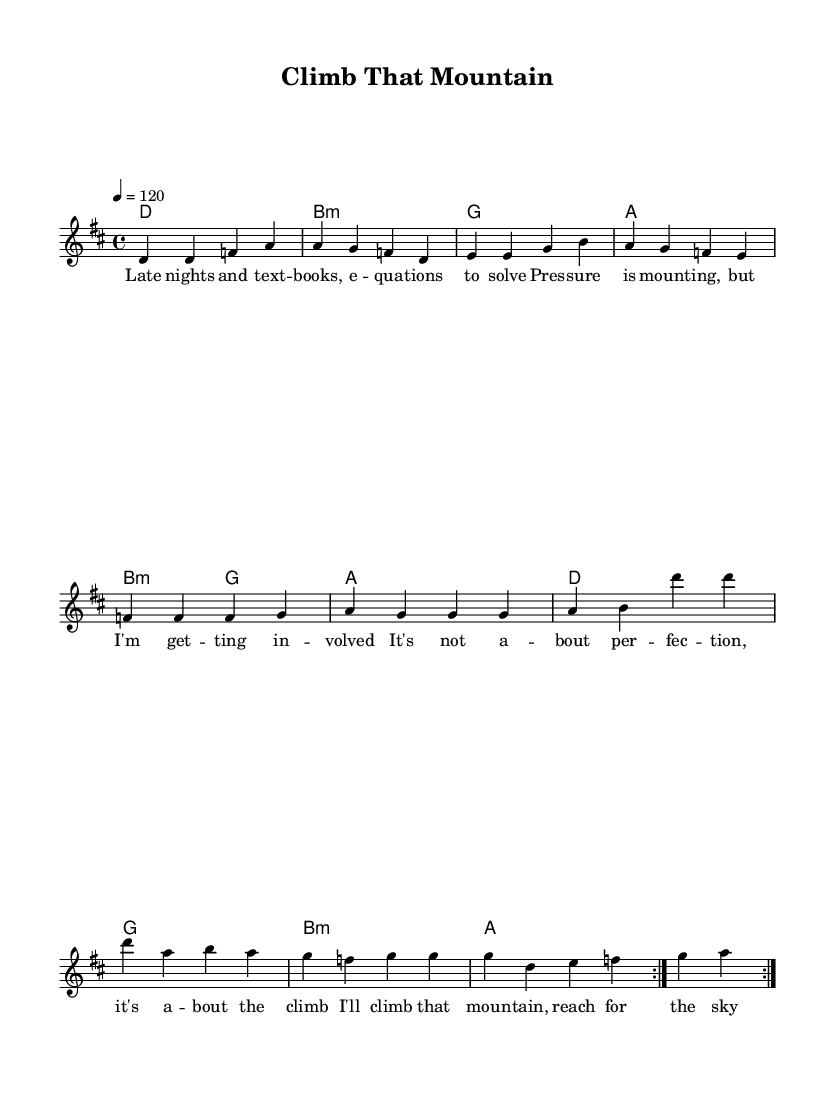What is the key signature of this music? The key signature is indicated at the beginning of the sheet music, showing two sharps, which corresponds to D major.
Answer: D major What is the time signature? The time signature is noted right after the key signature, represented by "4/4," which means there are four beats in each measure.
Answer: 4/4 What is the tempo marking for this piece? The tempo marking is given as "4 = 120," indicating that the quarter note is to be played at a speed of 120 beats per minute.
Answer: 120 How many repetitions are indicated in the melody section? The music notation includes a "repeat volta 2" directive, indicating that the melody should be played twice.
Answer: 2 What type of song is "Climb That Mountain"? The lyrics suggest a theme of perseverance and motivation, categorizing it as a motivational rock anthem.
Answer: Motivational rock anthem How many chords are used in the harmony section? The harmony section lists specific chords which can be counted; there are six unique chords indicated: D, B minor, G, A.
Answer: 4 